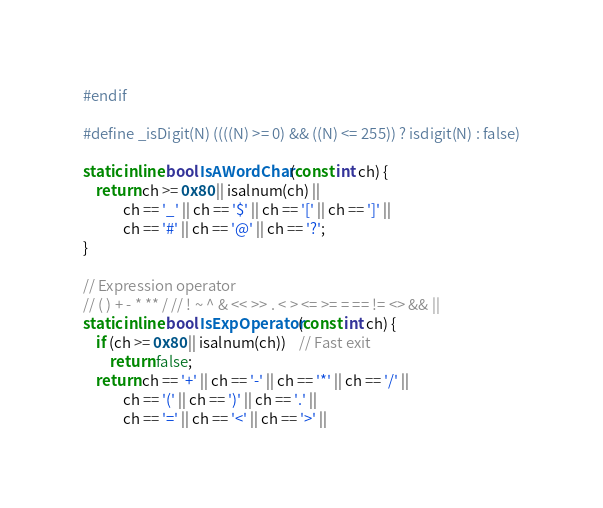Convert code to text. <code><loc_0><loc_0><loc_500><loc_500><_C++_>#endif

#define _isDigit(N) ((((N) >= 0) && ((N) <= 255)) ? isdigit(N) : false)

static inline bool IsAWordChar(const int ch) {
	return ch >= 0x80 || isalnum(ch) ||
			ch == '_' || ch == '$' || ch == '[' || ch == ']' ||
			ch == '#' || ch == '@' || ch == '?';
}

// Expression operator
// ( ) + - * ** / // ! ~ ^ & << >> . < > <= >= = == != <> && ||
static inline bool IsExpOperator(const int ch) {
	if (ch >= 0x80 || isalnum(ch))	// Fast exit
		return false;
	return ch == '+' || ch == '-' || ch == '*' || ch == '/' ||
			ch == '(' || ch == ')' || ch == '.' ||
			ch == '=' || ch == '<' || ch == '>' ||</code> 